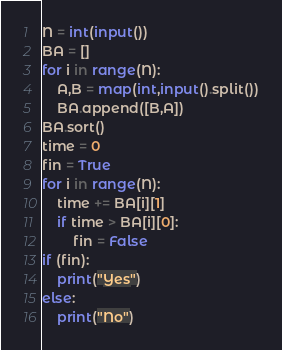<code> <loc_0><loc_0><loc_500><loc_500><_Python_>N = int(input())
BA = []
for i in range(N):
    A,B = map(int,input().split())
    BA.append([B,A])
BA.sort()
time = 0
fin = True
for i in range(N):
    time += BA[i][1]
    if time > BA[i][0]:
        fin = False
if (fin):
    print("Yes")
else:
    print("No")</code> 